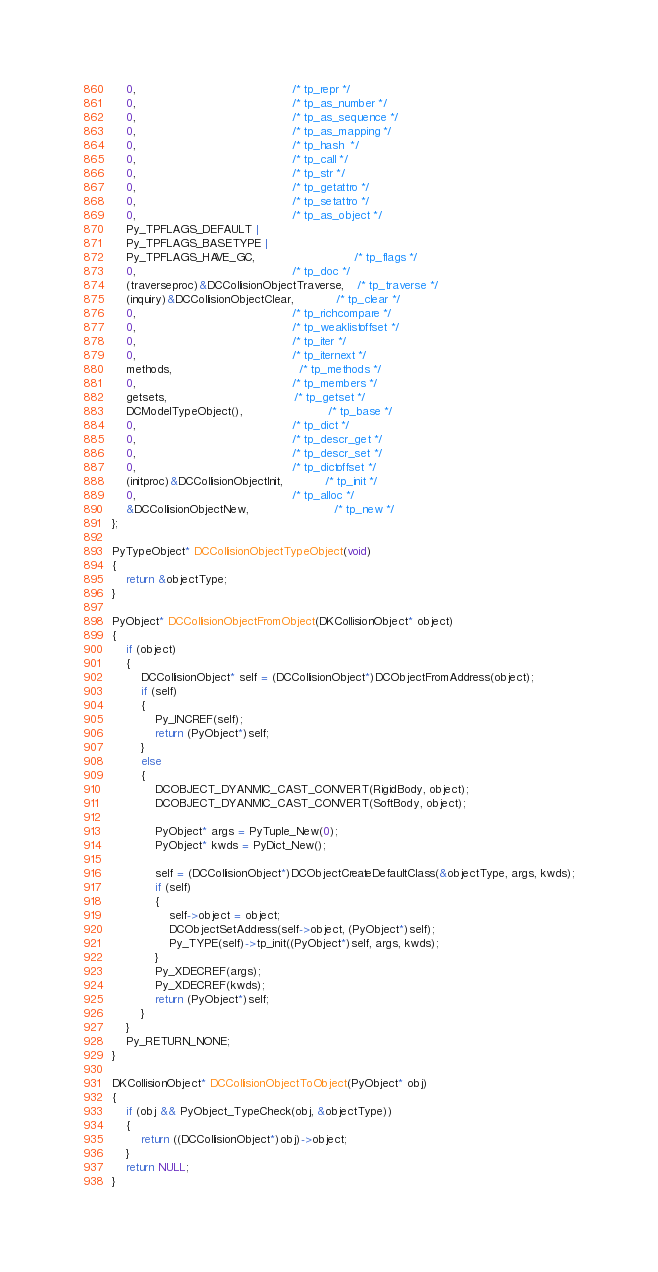<code> <loc_0><loc_0><loc_500><loc_500><_C++_>	0,											/* tp_repr */
	0,											/* tp_as_number */
	0,											/* tp_as_sequence */
	0,											/* tp_as_mapping */
	0,											/* tp_hash  */
	0,											/* tp_call */
	0,											/* tp_str */
	0,											/* tp_getattro */
	0,											/* tp_setattro */
	0,											/* tp_as_object */
	Py_TPFLAGS_DEFAULT |
	Py_TPFLAGS_BASETYPE |
	Py_TPFLAGS_HAVE_GC,							/* tp_flags */
	0,											/* tp_doc */
	(traverseproc)&DCCollisionObjectTraverse,	/* tp_traverse */
	(inquiry)&DCCollisionObjectClear,			/* tp_clear */
	0,											/* tp_richcompare */
	0,											/* tp_weaklistoffset */
	0,											/* tp_iter */
	0,											/* tp_iternext */
	methods,									/* tp_methods */
	0,											/* tp_members */
	getsets,									/* tp_getset */
	DCModelTypeObject(),						/* tp_base */
	0,											/* tp_dict */
	0,											/* tp_descr_get */
	0,											/* tp_descr_set */
	0,											/* tp_dictoffset */
	(initproc)&DCCollisionObjectInit,			/* tp_init */
	0,											/* tp_alloc */
	&DCCollisionObjectNew,						/* tp_new */
};

PyTypeObject* DCCollisionObjectTypeObject(void)
{
	return &objectType;
}

PyObject* DCCollisionObjectFromObject(DKCollisionObject* object)
{
	if (object)
	{
		DCCollisionObject* self = (DCCollisionObject*)DCObjectFromAddress(object);
		if (self)
		{
			Py_INCREF(self);
			return (PyObject*)self;
		}
		else
		{
			DCOBJECT_DYANMIC_CAST_CONVERT(RigidBody, object);
			DCOBJECT_DYANMIC_CAST_CONVERT(SoftBody, object);

			PyObject* args = PyTuple_New(0);
			PyObject* kwds = PyDict_New();

			self = (DCCollisionObject*)DCObjectCreateDefaultClass(&objectType, args, kwds);
			if (self)
			{
				self->object = object;
				DCObjectSetAddress(self->object, (PyObject*)self);
				Py_TYPE(self)->tp_init((PyObject*)self, args, kwds);
			}
			Py_XDECREF(args);
			Py_XDECREF(kwds);
			return (PyObject*)self;
		}
	}
	Py_RETURN_NONE;
}

DKCollisionObject* DCCollisionObjectToObject(PyObject* obj)
{
	if (obj && PyObject_TypeCheck(obj, &objectType))
	{
		return ((DCCollisionObject*)obj)->object;
	}
	return NULL;
}
</code> 